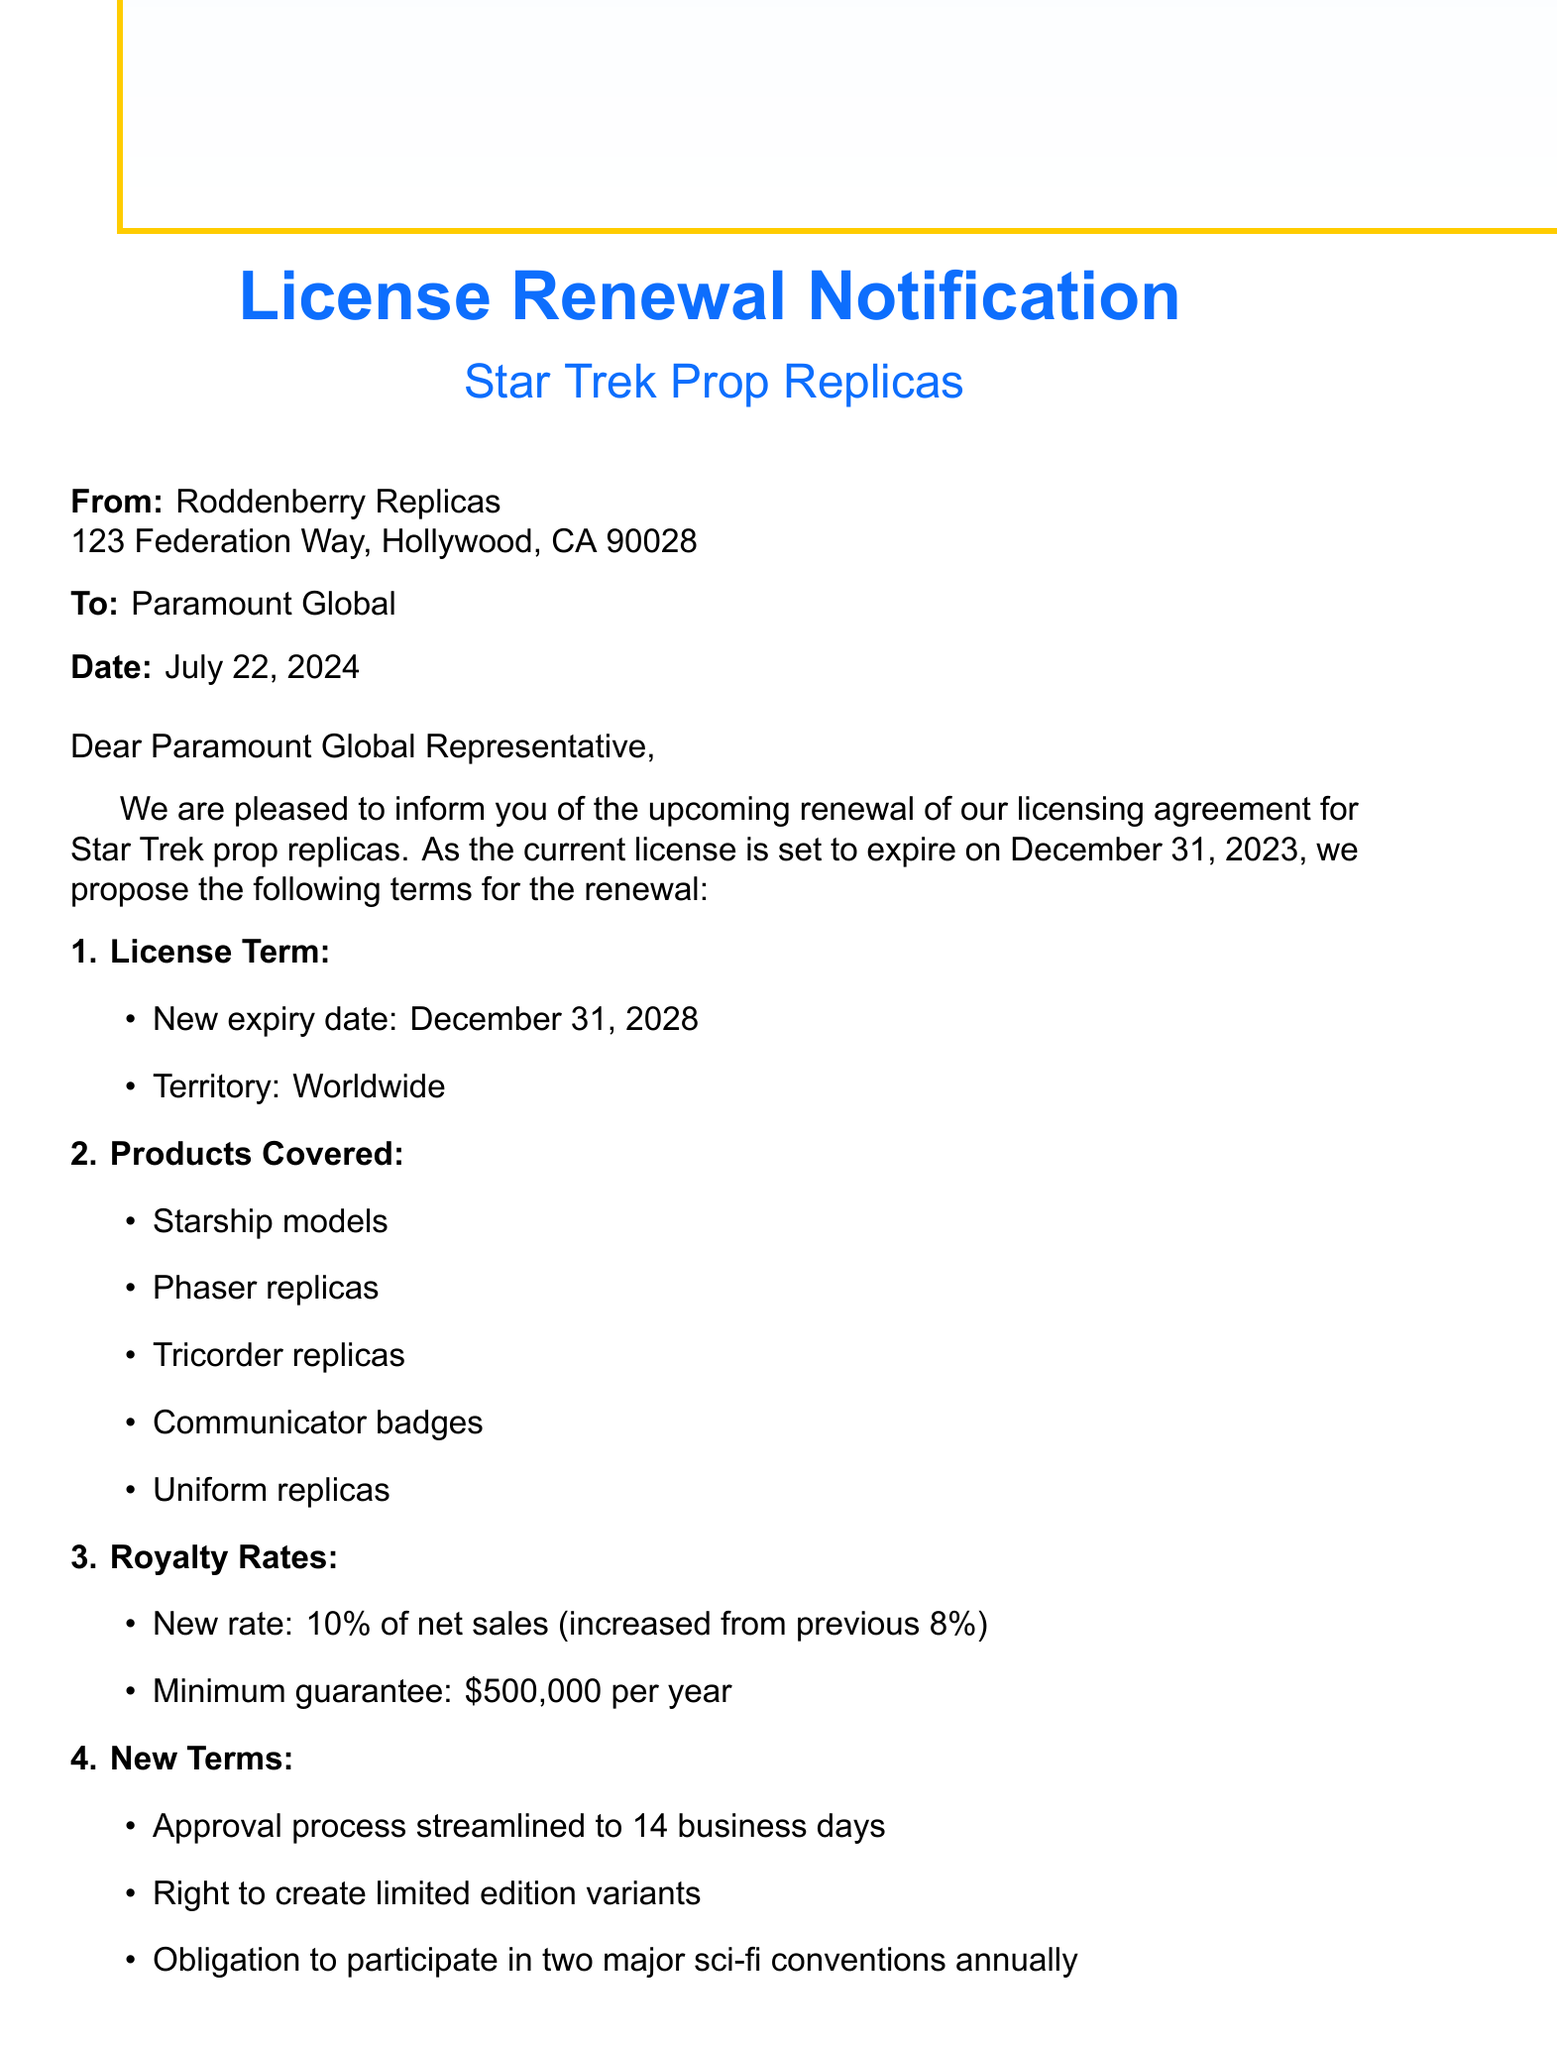What is the name of the franchise? The name of the franchise is mentioned in the document as "Star Trek."
Answer: Star Trek Who is the owner of the franchise? The document specifies that the owner of the franchise is "Paramount Global."
Answer: Paramount Global What is the new expiry date of the license? The new expiry date of the license is stated as "December 31, 2028."
Answer: December 31, 2028 What are the new royalty rates for net sales? The document clearly states that the new royalty rate is "10% of net sales."
Answer: 10% of net sales What is the minimum guarantee per year? According to the document, the minimum guarantee is "$500,000 per year."
Answer: $500,000 per year How long will the approval process take? The document indicates that the approval process is streamlined to "14 business days."
Answer: 14 business days What is required for quality control regarding new products? The document specifies that "5 units of each new product" must be submitted for sample submission as part of quality control.
Answer: 5 units of each new product Where is the governing law for the agreement? The governing law specified in the document is "State of California."
Answer: State of California 